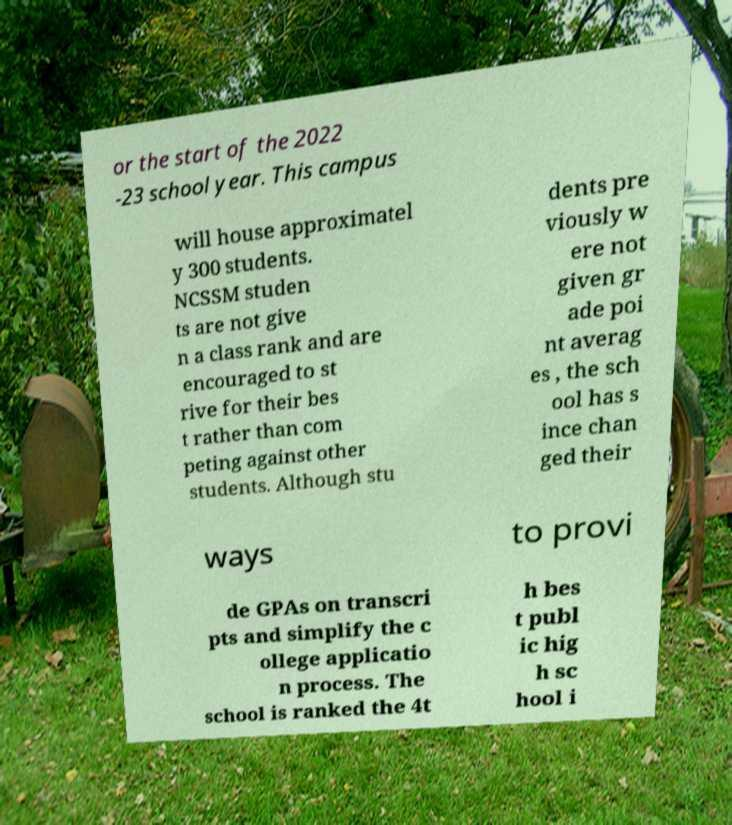I need the written content from this picture converted into text. Can you do that? or the start of the 2022 -23 school year. This campus will house approximatel y 300 students. NCSSM studen ts are not give n a class rank and are encouraged to st rive for their bes t rather than com peting against other students. Although stu dents pre viously w ere not given gr ade poi nt averag es , the sch ool has s ince chan ged their ways to provi de GPAs on transcri pts and simplify the c ollege applicatio n process. The school is ranked the 4t h bes t publ ic hig h sc hool i 